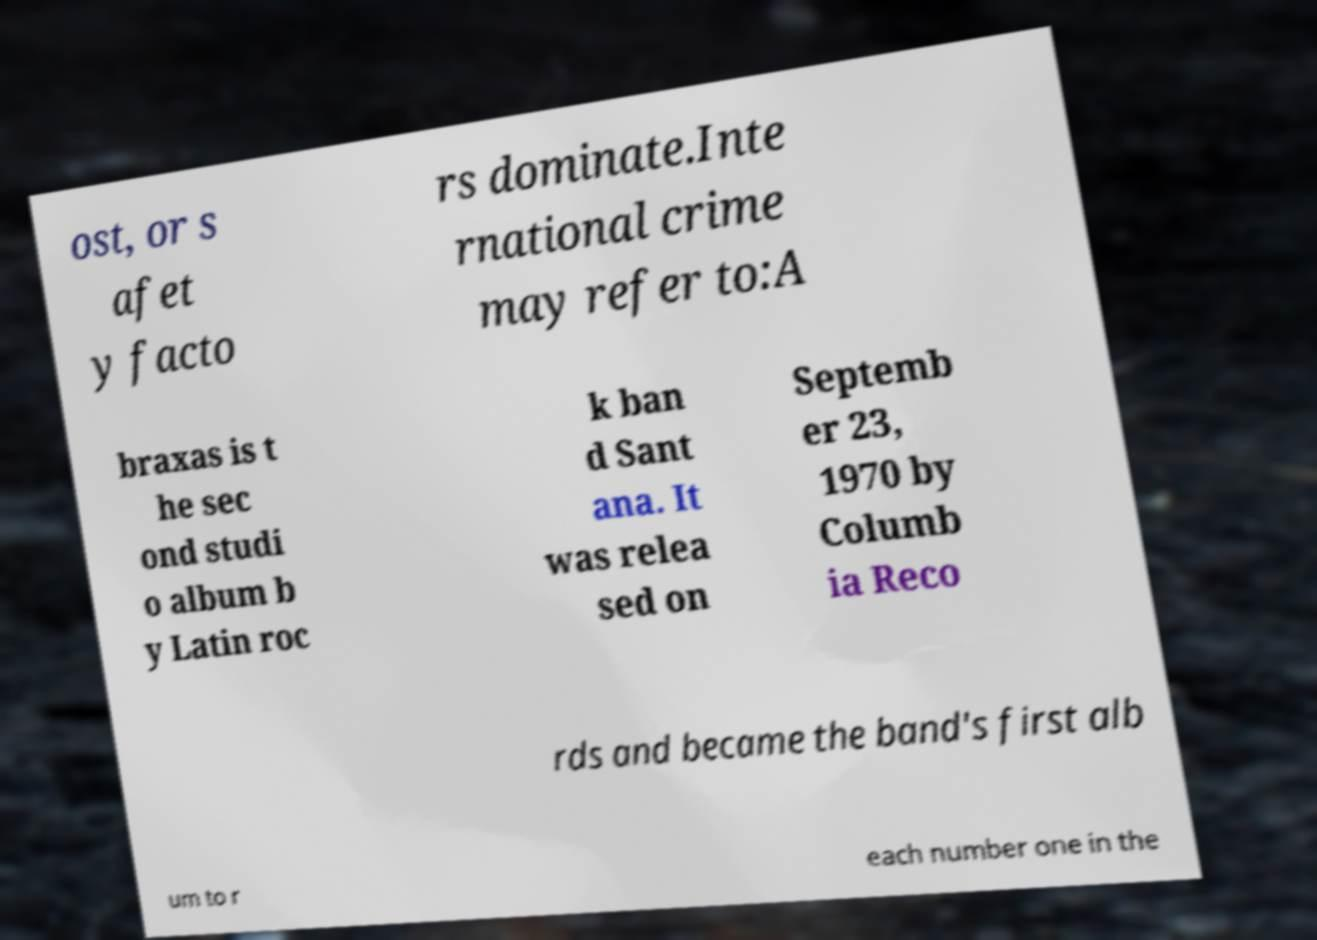There's text embedded in this image that I need extracted. Can you transcribe it verbatim? ost, or s afet y facto rs dominate.Inte rnational crime may refer to:A braxas is t he sec ond studi o album b y Latin roc k ban d Sant ana. It was relea sed on Septemb er 23, 1970 by Columb ia Reco rds and became the band's first alb um to r each number one in the 